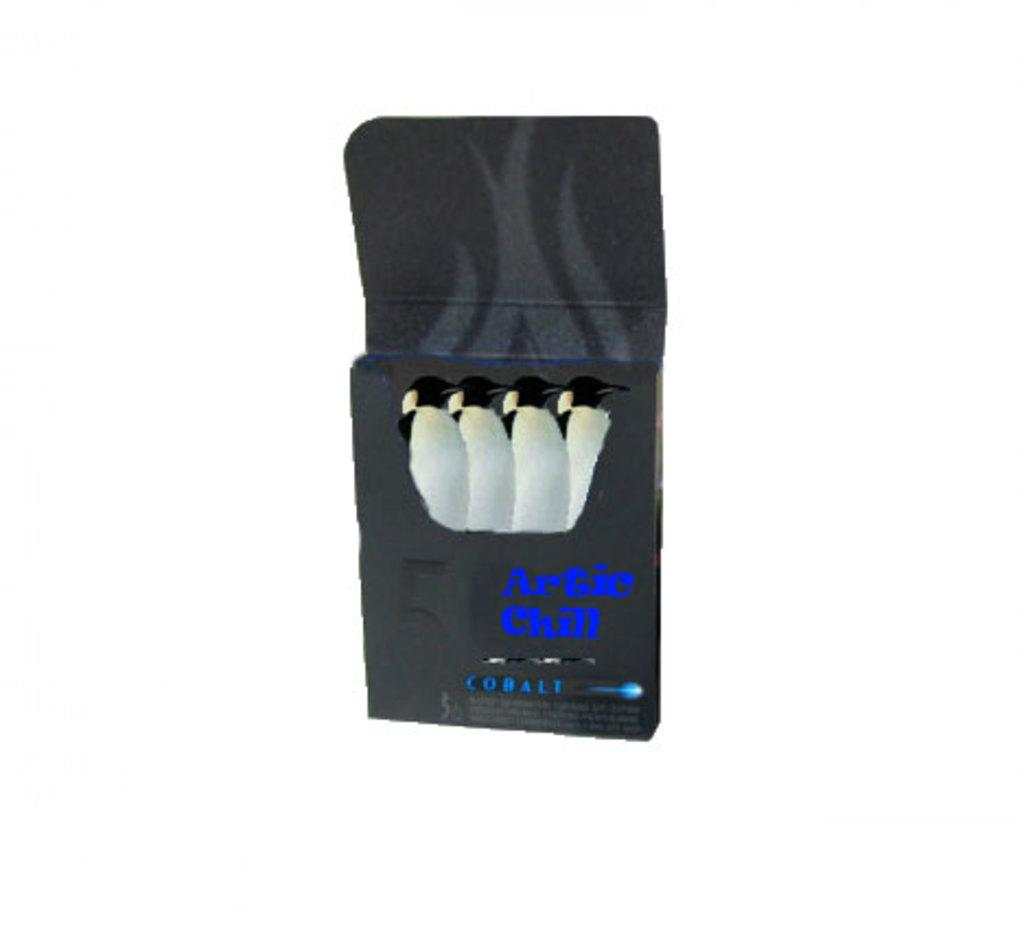Provide a one-sentence caption for the provided image. A black box of penguins says Artic Chill Cobalt. 